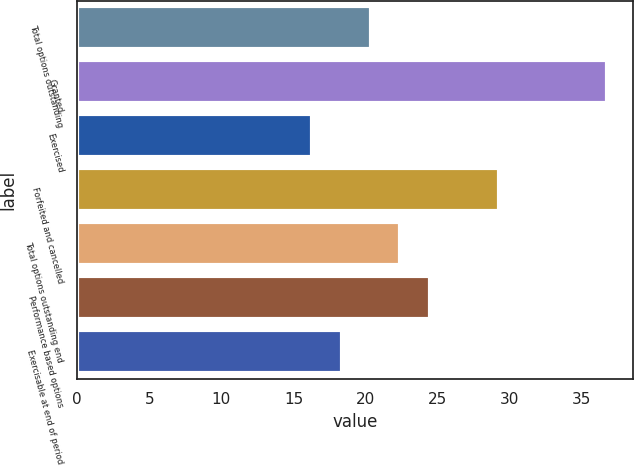Convert chart to OTSL. <chart><loc_0><loc_0><loc_500><loc_500><bar_chart><fcel>Total options outstanding<fcel>Granted<fcel>Exercised<fcel>Forfeited and cancelled<fcel>Total options outstanding end<fcel>Performance based options<fcel>Exercisable at end of period<nl><fcel>20.38<fcel>36.75<fcel>16.3<fcel>29.26<fcel>22.42<fcel>24.47<fcel>18.34<nl></chart> 